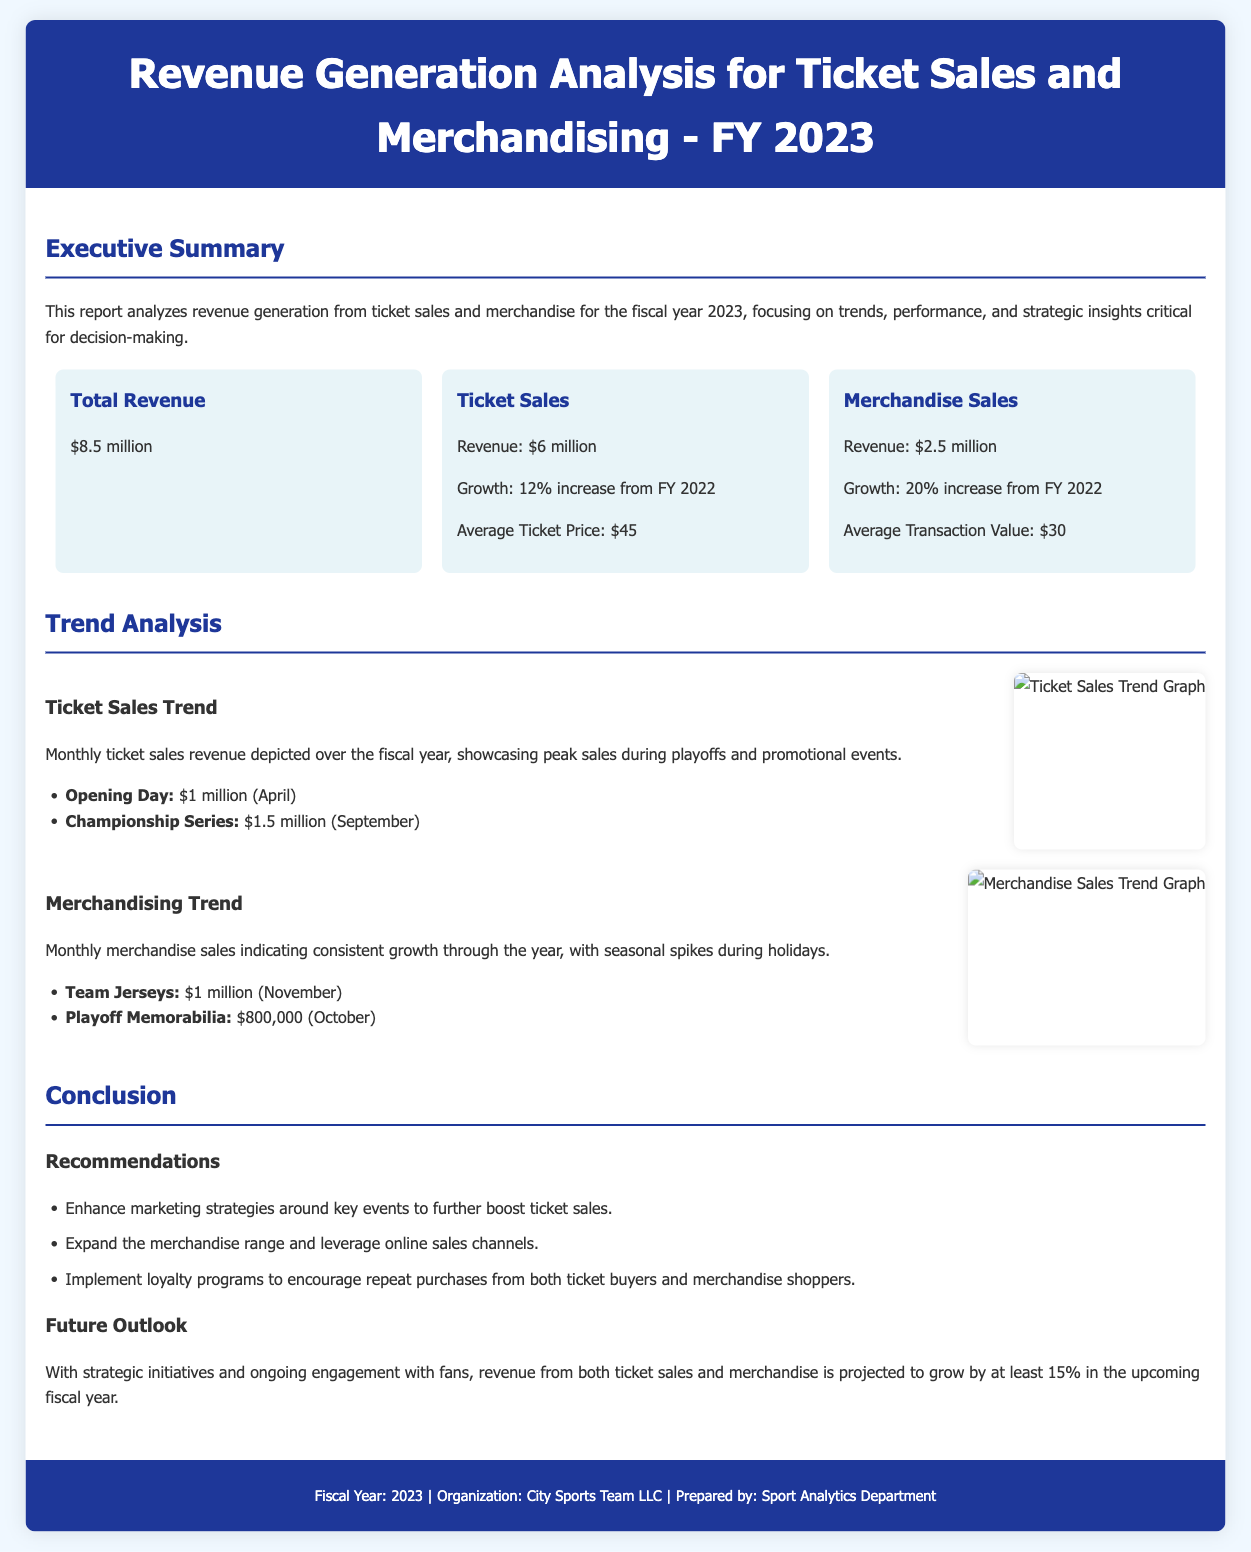What is the total revenue for FY 2023? The total revenue is the full sum of revenue sources listed in the document, which is $6 million from ticket sales plus $2.5 million from merchandise.
Answer: $8.5 million What is the revenue generated from ticket sales? The document specifies that ticket sales revenue amounts to $6 million.
Answer: $6 million What was the growth percentage for merchandise sales? The report states a growth of 20% from FY 2022 for merchandise sales.
Answer: 20% What was the average ticket price? The average ticket price is mentioned as $45 in the document.
Answer: $45 When did the peak ticket sales occur? The document lists peak sales during the Championship Series in September.
Answer: September What is the average transaction value for merchandise sales? The document indicates that the average transaction value for merchandise sales is $30.
Answer: $30 How much revenue was generated from team jerseys in November? The report mentions that team jerseys generated $1 million in revenue during November.
Answer: $1 million What are the recommendations for future sales strategies? The recommendations include enhancing marketing strategies, expanding the merchandise range, and implementing loyalty programs.
Answer: Enhance marketing strategies, expand merchandise range, implement loyalty programs 